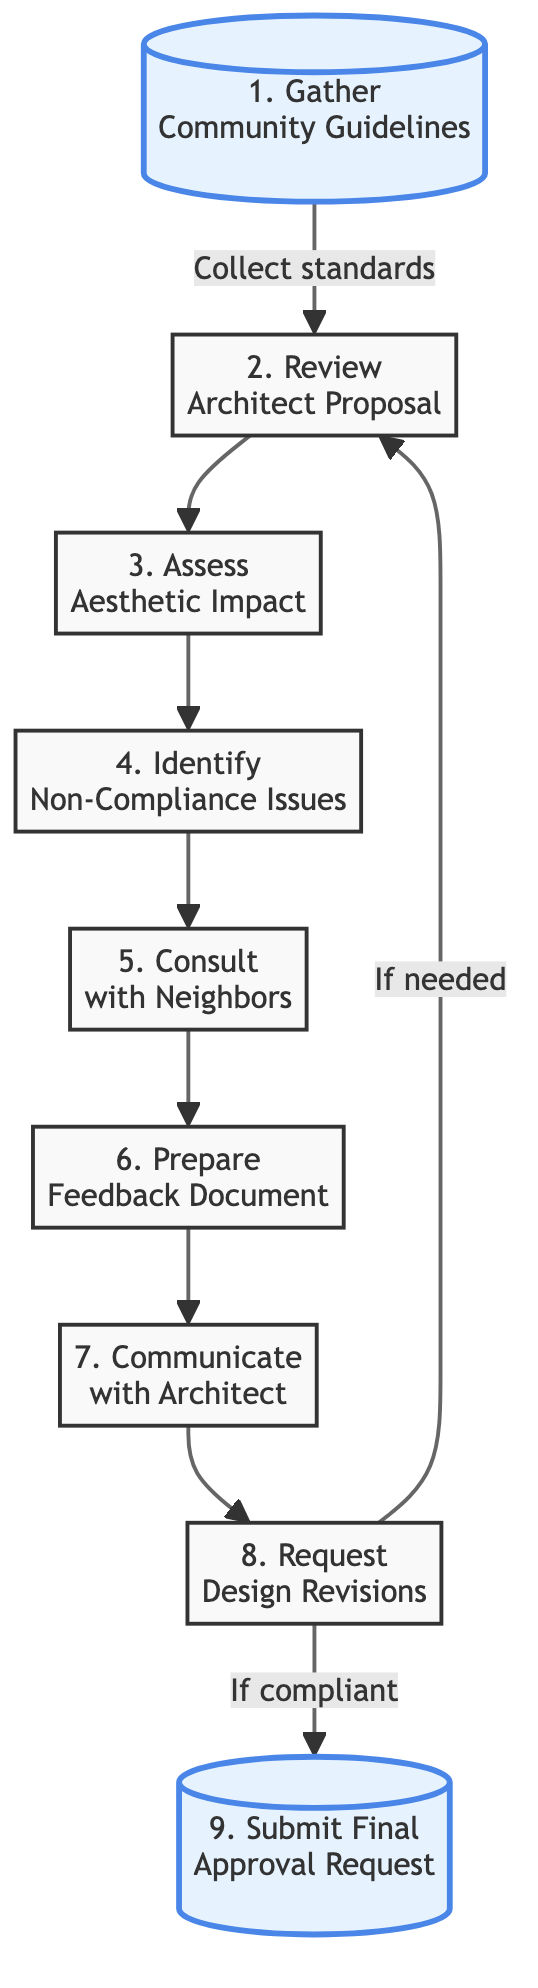What is the first step in the flow chart? The first step, as indicated in the diagram, is "Gather Community Guidelines". This is represented as the starting point from which the flow proceeds.
Answer: Gather Community Guidelines How many total steps are in the flow chart? To determine the total number of steps, I counted each distinct node in the flow chart, which amounts to nine.
Answer: 9 What does the step "Request Design Revisions" connect to if needed? The step "Request Design Revisions" has a connection leading back to the "Review Architect Proposal" step if design modifications are necessary. This indicates a cyclical relationship to ensure compliance.
Answer: Review Architect Proposal What is assessed in the "Assess Aesthetic Impact" step? In the "Assess Aesthetic Impact" step, the diagram indicates that the focus is on evaluating how the architect's design fits within the overall neighborhood look and feel.
Answer: Evaluate neighborhood fit Which step involves gathering opinions from neighboring homeowners? The step dedicated to this activity is "Consult with Neighbors", where discussions with nearby homeowners happen regarding their opinions on the proposal.
Answer: Consult with Neighbors If the proposal is compliant, where does it go next? If the proposal is found compliant after revisions, the next step is to "Submit Final Approval Request," indicating the conclusion of the review process.
Answer: Submit Final Approval Request Which node precedes the "Communicate with Architect" step? The node that comes right before "Communicate with Architect" is "Prepare Feedback Document", meaning that feedback must be compiled prior to discussing issues with the architect.
Answer: Prepare Feedback Document What is the primary purpose of the "Identify Non-Compliance Issues" step? The purpose of "Identify Non-Compliance Issues" is to denote and note any elements in the proposal that do not align with community standards, which is crucial for maintaining the neighborhood aesthetic.
Answer: Note non-compliance issues What action follows after "Assess Aesthetic Impact"? After "Assess Aesthetic Impact", the next action in the flow chart is "Identify Non-Compliance Issues", indicating a logical progression toward evaluating compliance with guidelines.
Answer: Identify Non-Compliance Issues 